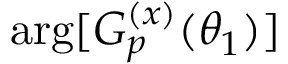Convert formula to latex. <formula><loc_0><loc_0><loc_500><loc_500>\arg [ G _ { p } ^ { ( x ) } ( \theta _ { 1 } ) ]</formula> 